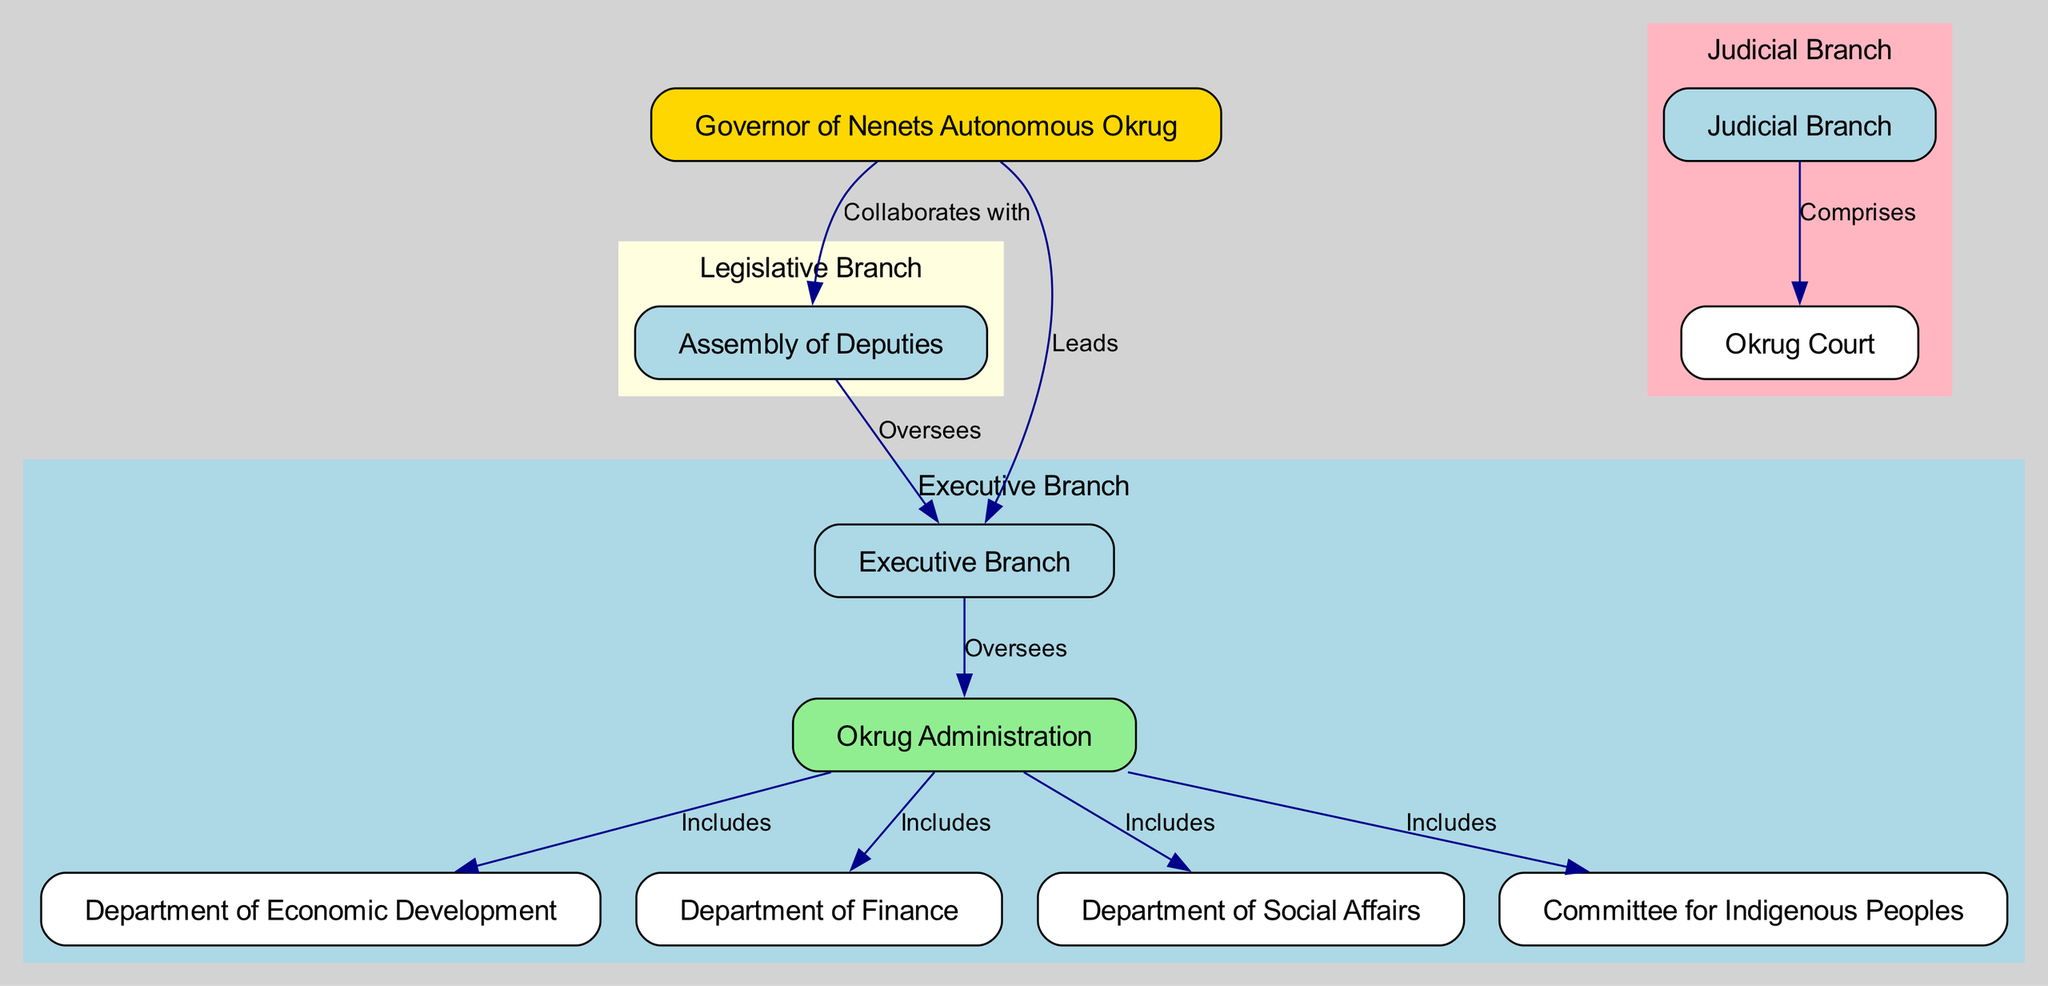What is the top position in the Nenets Autonomous Okrug government structure? The diagram indicates the "Governor of Nenets Autonomous Okrug" at the top of the organizational chart, establishing it as the highest authority in the structure.
Answer: Governor of Nenets Autonomous Okrug How many nodes are present in the diagram? The diagram lists 10 distinct nodes representing various entities within the government structure, which can be counted directly from the provided data.
Answer: 10 What branch does the Assembly of Deputies oversee? The edge connecting the Assembly of Deputies to the Executive Branch indicates oversight, suggesting that the Assembly has a subordinate role to the Executive.
Answer: Executive Branch Which position collaborates with the Governor? The data shows an edge labeled "Collaborates with" connecting the Governor to the Assembly of Deputies, indicating this relationship of collaboration.
Answer: Assembly of Deputies What department is included in the Okrug Administration? The diagram illustrates that the Department of Economic Development is one of several entities that falls under the umbrella of the Okrug Administration, as indicated by the "Includes" relationship.
Answer: Department of Economic Development Which branch comprises the Okrug Court? The diagram specifies that the Judicial Branch contains the Okrug Court, demonstrating its role as part of that larger structure.
Answer: Judicial Branch How many departments fall under the Okrug Administration? The diagram shows four departments linked to the Okrug Administration labeled "Includes," indicating that these represent its subdivisions.
Answer: 4 What type of relationship exists between the Executive Branch and the Okrug Administration? The diagram depicts an "Oversees" relationship connecting the Executive Branch to the Okrug Administration, signifying the level of control or supervision exerted.
Answer: Oversees What is the function of the Committee for Indigenous Peoples? In the diagram, the Committee for Indigenous Peoples is listed as one of the departments included under the Okrug Administration but does not have a distinct relational label beyond that. Thus, its function relates to indigenous affairs as part of the Administration's responsibilities.
Answer: Department within the Okrug Administration 